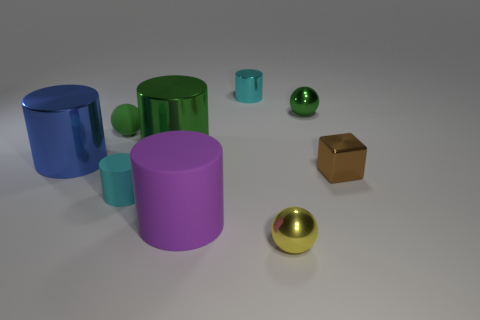What number of other objects are there of the same size as the yellow metal sphere?
Your response must be concise. 5. What number of small green objects have the same material as the purple cylinder?
Ensure brevity in your answer.  1. There is a cyan thing that is behind the brown shiny thing; what is its shape?
Make the answer very short. Cylinder. Are the big purple cylinder and the cyan thing left of the purple thing made of the same material?
Keep it short and to the point. Yes. Are there any small brown rubber blocks?
Keep it short and to the point. No. Are there any large blue things behind the yellow metallic ball that is in front of the small cylinder that is in front of the tiny cube?
Provide a short and direct response. Yes. How many large objects are either red balls or blue shiny cylinders?
Your answer should be very brief. 1. What color is the matte cylinder that is the same size as the green shiny ball?
Make the answer very short. Cyan. There is a yellow shiny ball; what number of small green objects are to the right of it?
Keep it short and to the point. 1. Are there any other cylinders that have the same material as the purple cylinder?
Provide a succinct answer. Yes. 